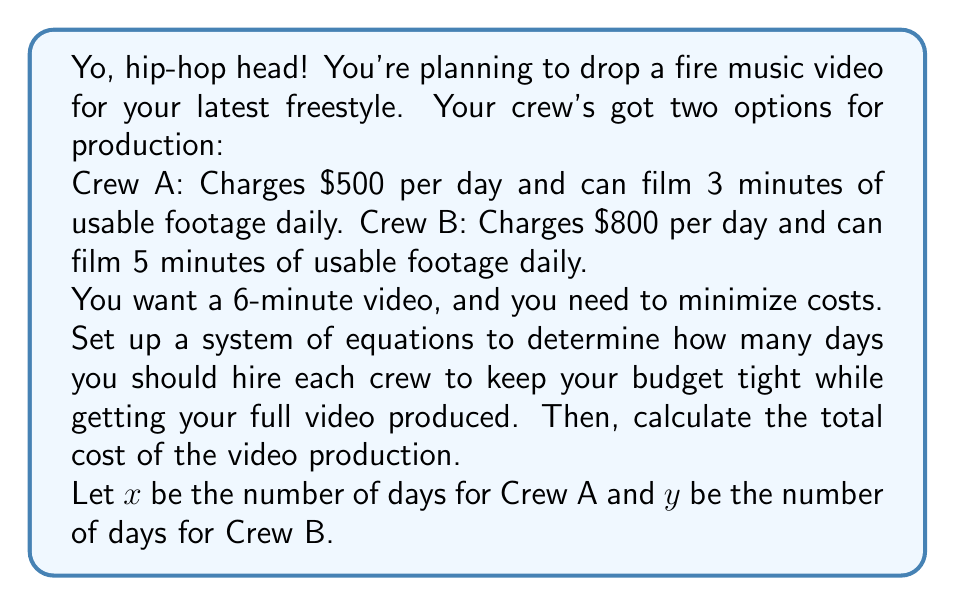Provide a solution to this math problem. Alright, let's break this down like we're dissecting a dope beat:

1) First, we need to ensure we get enough footage. This gives us our first equation:
   $$ 3x + 5y = 6 $$
   This represents the total minutes of footage (3 minutes/day from Crew A, 5 minutes/day from Crew B) equaling our desired 6-minute video.

2) Now, we want to minimize cost. Let's express the total cost in terms of $x$ and $y$:
   $$ \text{Total Cost} = 500x + 800y $$

3) To solve this, we need to express $y$ in terms of $x$ using our first equation:
   $$ y = \frac{6 - 3x}{5} $$

4) Substitute this into our cost equation:
   $$ \text{Total Cost} = 500x + 800(\frac{6 - 3x}{5}) $$

5) Simplify:
   $$ \text{Total Cost} = 500x + 960 - 480x = 960 + 20x $$

6) To minimize cost, we want $x$ to be as large as possible (since the coefficient is positive). But remember, $x$ and $y$ must be non-negative integers.

7) The maximum integer value for $x$ that keeps $y$ non-negative is 2:
   When $x = 2$, $y = \frac{6 - 3(2)}{5} = 0$
   
8) Therefore, the optimal solution is $x = 2$ (days with Crew A) and $y = 0$ (days with Crew B)

9) Calculate the total cost:
   $$ \text{Total Cost} = 500(2) + 800(0) = 1000 $$
Answer: Hire Crew A for 2 days and Crew B for 0 days. The total cost will be $1000. 